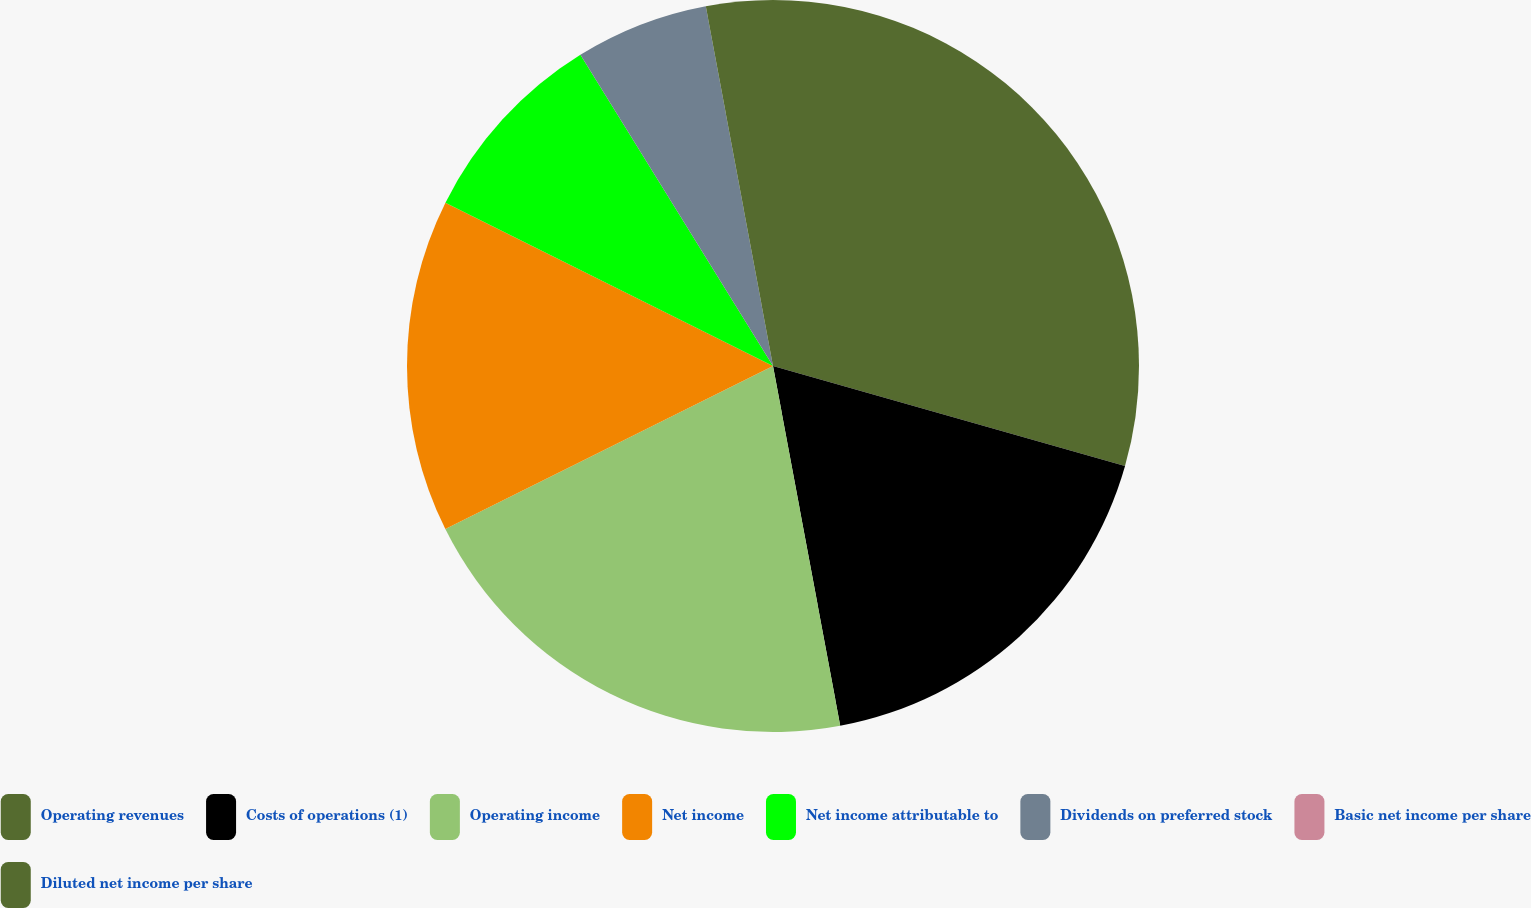<chart> <loc_0><loc_0><loc_500><loc_500><pie_chart><fcel>Operating revenues<fcel>Costs of operations (1)<fcel>Operating income<fcel>Net income<fcel>Net income attributable to<fcel>Dividends on preferred stock<fcel>Basic net income per share<fcel>Diluted net income per share<nl><fcel>29.41%<fcel>17.65%<fcel>20.59%<fcel>14.71%<fcel>8.82%<fcel>5.88%<fcel>0.0%<fcel>2.94%<nl></chart> 